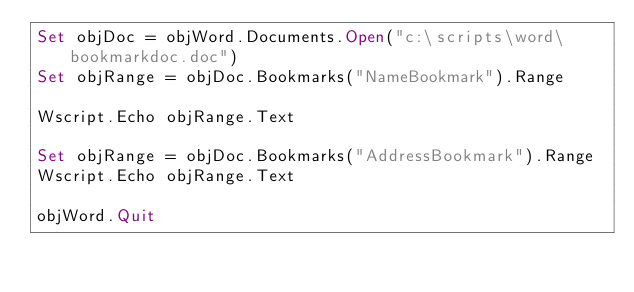<code> <loc_0><loc_0><loc_500><loc_500><_VisualBasic_>Set objDoc = objWord.Documents.Open("c:\scripts\word\bookmarkdoc.doc")
Set objRange = objDoc.Bookmarks("NameBookmark").Range

Wscript.Echo objRange.Text 

Set objRange = objDoc.Bookmarks("AddressBookmark").Range
Wscript.Echo objRange.Text 

objWord.Quit

</code> 